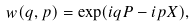<formula> <loc_0><loc_0><loc_500><loc_500>w ( q , p ) = \exp ( i q P - i p X ) ,</formula> 